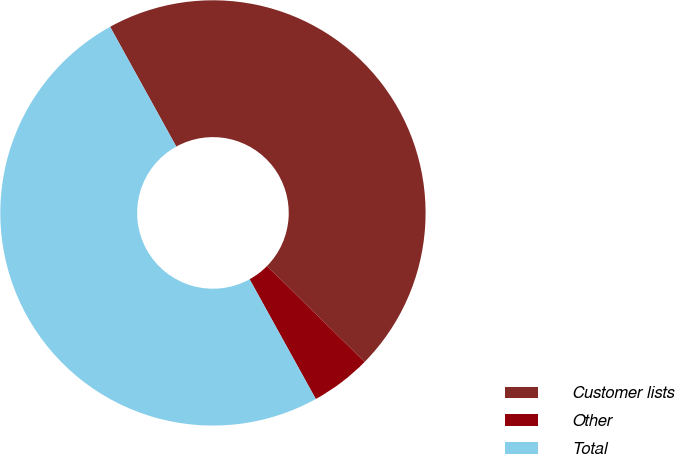<chart> <loc_0><loc_0><loc_500><loc_500><pie_chart><fcel>Customer lists<fcel>Other<fcel>Total<nl><fcel>45.39%<fcel>4.61%<fcel>50.0%<nl></chart> 